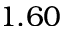Convert formula to latex. <formula><loc_0><loc_0><loc_500><loc_500>1 . 6 0</formula> 